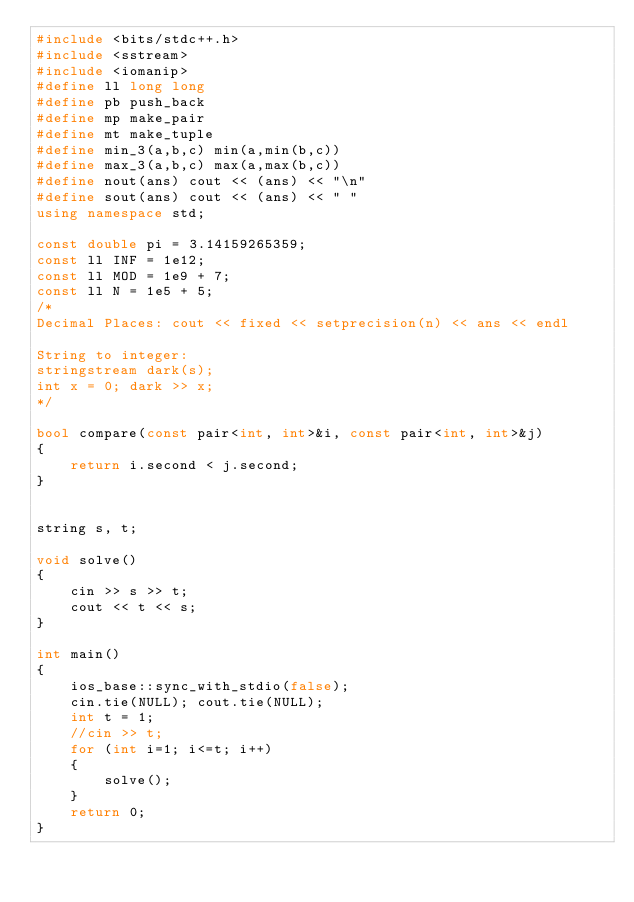Convert code to text. <code><loc_0><loc_0><loc_500><loc_500><_C++_>#include <bits/stdc++.h>
#include <sstream>
#include <iomanip>
#define ll long long
#define pb push_back
#define mp make_pair
#define mt make_tuple
#define min_3(a,b,c) min(a,min(b,c))
#define max_3(a,b,c) max(a,max(b,c))
#define nout(ans) cout << (ans) << "\n"
#define sout(ans) cout << (ans) << " "
using namespace std;

const double pi = 3.14159265359;
const ll INF = 1e12;
const ll MOD = 1e9 + 7;
const ll N = 1e5 + 5;
/*
Decimal Places: cout << fixed << setprecision(n) << ans << endl

String to integer:
stringstream dark(s);
int x = 0; dark >> x;
*/

bool compare(const pair<int, int>&i, const pair<int, int>&j)
{
    return i.second < j.second;
}


string s, t;

void solve()
{
    cin >> s >> t;
    cout << t << s;
}

int main()
{
    ios_base::sync_with_stdio(false);
    cin.tie(NULL); cout.tie(NULL);
    int t = 1;
    //cin >> t;
    for (int i=1; i<=t; i++)
    {
        solve();
    }
    return 0;
}</code> 